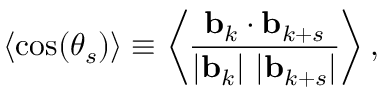Convert formula to latex. <formula><loc_0><loc_0><loc_500><loc_500>\langle \cos ( \theta _ { s } ) \rangle \equiv \left \langle \frac { \mathbf b _ { k } \cdot \mathbf b _ { k + s } } { | \mathbf b _ { k } | \ | \mathbf b _ { k + s } | } \right \rangle ,</formula> 